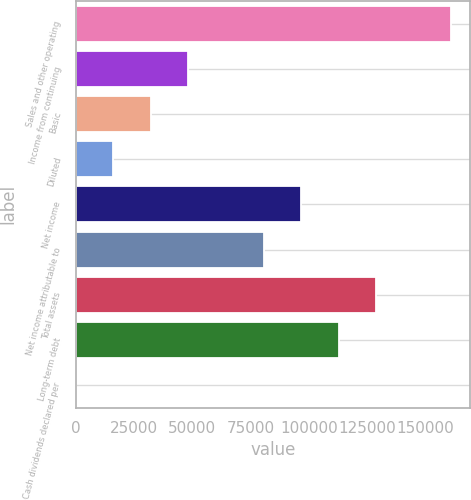Convert chart. <chart><loc_0><loc_0><loc_500><loc_500><bar_chart><fcel>Sales and other operating<fcel>Income from continuing<fcel>Basic<fcel>Diluted<fcel>Net income<fcel>Net income attributable to<fcel>Total assets<fcel>Long-term debt<fcel>Cash dividends declared per<nl><fcel>161212<fcel>48364.9<fcel>32243.9<fcel>16122.9<fcel>96727.9<fcel>80606.9<fcel>128970<fcel>112849<fcel>1.89<nl></chart> 